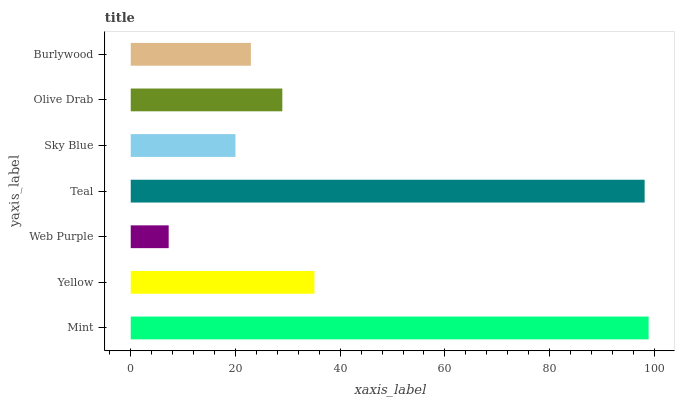Is Web Purple the minimum?
Answer yes or no. Yes. Is Mint the maximum?
Answer yes or no. Yes. Is Yellow the minimum?
Answer yes or no. No. Is Yellow the maximum?
Answer yes or no. No. Is Mint greater than Yellow?
Answer yes or no. Yes. Is Yellow less than Mint?
Answer yes or no. Yes. Is Yellow greater than Mint?
Answer yes or no. No. Is Mint less than Yellow?
Answer yes or no. No. Is Olive Drab the high median?
Answer yes or no. Yes. Is Olive Drab the low median?
Answer yes or no. Yes. Is Burlywood the high median?
Answer yes or no. No. Is Burlywood the low median?
Answer yes or no. No. 